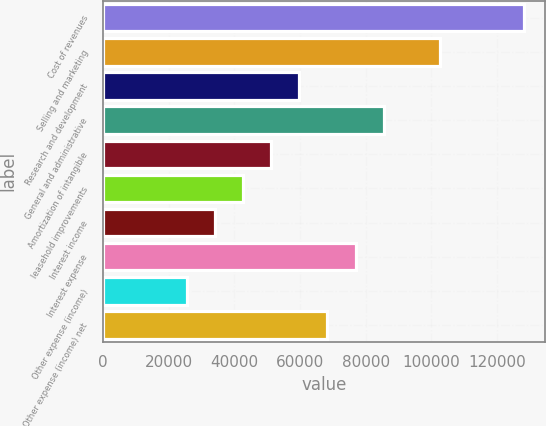Convert chart to OTSL. <chart><loc_0><loc_0><loc_500><loc_500><bar_chart><fcel>Cost of revenues<fcel>Selling and marketing<fcel>Research and development<fcel>General and administrative<fcel>Amortization of intangible<fcel>leasehold improvements<fcel>Interest income<fcel>Interest expense<fcel>Other expense (income)<fcel>Other expense (income) net<nl><fcel>128154<fcel>102523<fcel>59805.3<fcel>85436<fcel>51261.8<fcel>42718.3<fcel>34174.7<fcel>76892.4<fcel>25631.2<fcel>68348.9<nl></chart> 